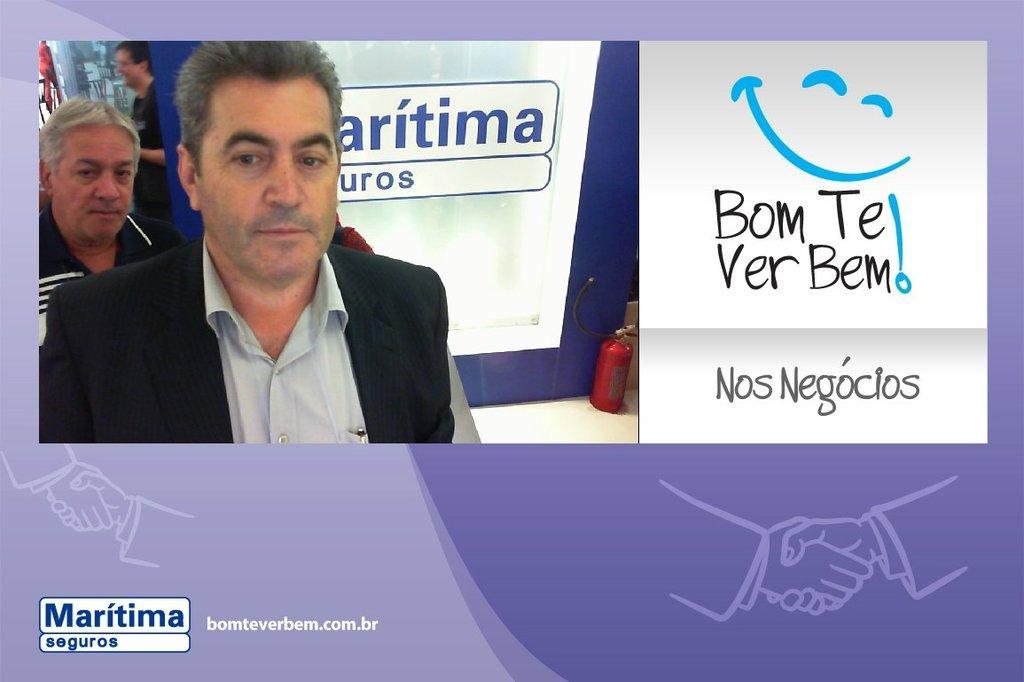Please provide a concise description of this image. In this image there are some persons boards, cylinder and some objects, and on the right side of the image there is text. And at the bottom of the image there is an animation of persons hands who are shaking their hands with each other, and at the bottom of the image there is text. 